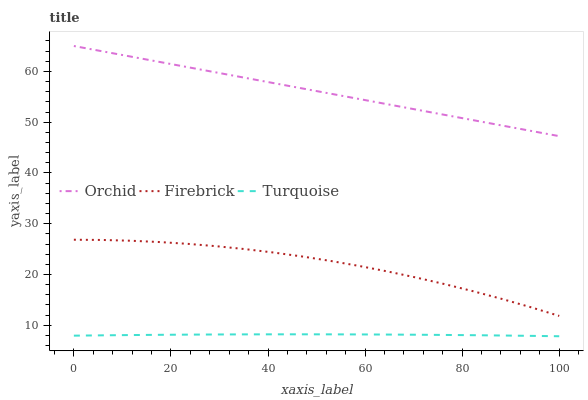Does Turquoise have the minimum area under the curve?
Answer yes or no. Yes. Does Orchid have the maximum area under the curve?
Answer yes or no. Yes. Does Orchid have the minimum area under the curve?
Answer yes or no. No. Does Turquoise have the maximum area under the curve?
Answer yes or no. No. Is Orchid the smoothest?
Answer yes or no. Yes. Is Firebrick the roughest?
Answer yes or no. Yes. Is Turquoise the smoothest?
Answer yes or no. No. Is Turquoise the roughest?
Answer yes or no. No. Does Turquoise have the lowest value?
Answer yes or no. Yes. Does Orchid have the lowest value?
Answer yes or no. No. Does Orchid have the highest value?
Answer yes or no. Yes. Does Turquoise have the highest value?
Answer yes or no. No. Is Firebrick less than Orchid?
Answer yes or no. Yes. Is Orchid greater than Firebrick?
Answer yes or no. Yes. Does Firebrick intersect Orchid?
Answer yes or no. No. 